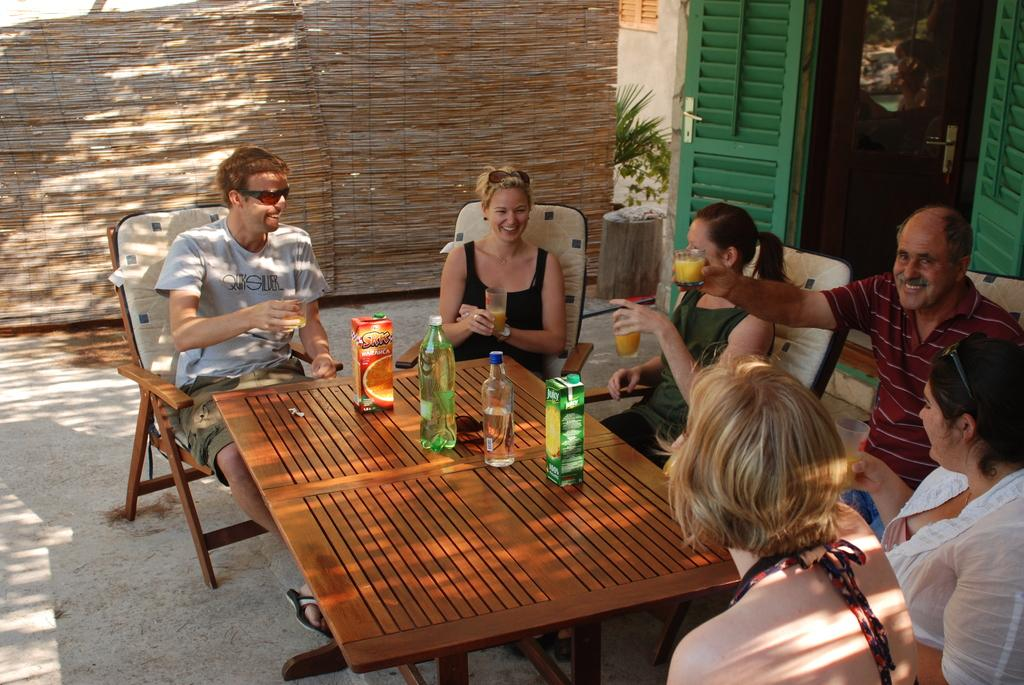How many people are in the image? There is a group of people in the image, but the exact number is not specified. What are the people holding in their hands? The people are holding glasses in their hands. What is in front of the people? There is a table in front of the people. What can be seen on the table? There are bottles on the table. Where is the cactus located in the image? There is no cactus present in the image. What type of can is visible on the table? There is no can visible on the table in the image. 